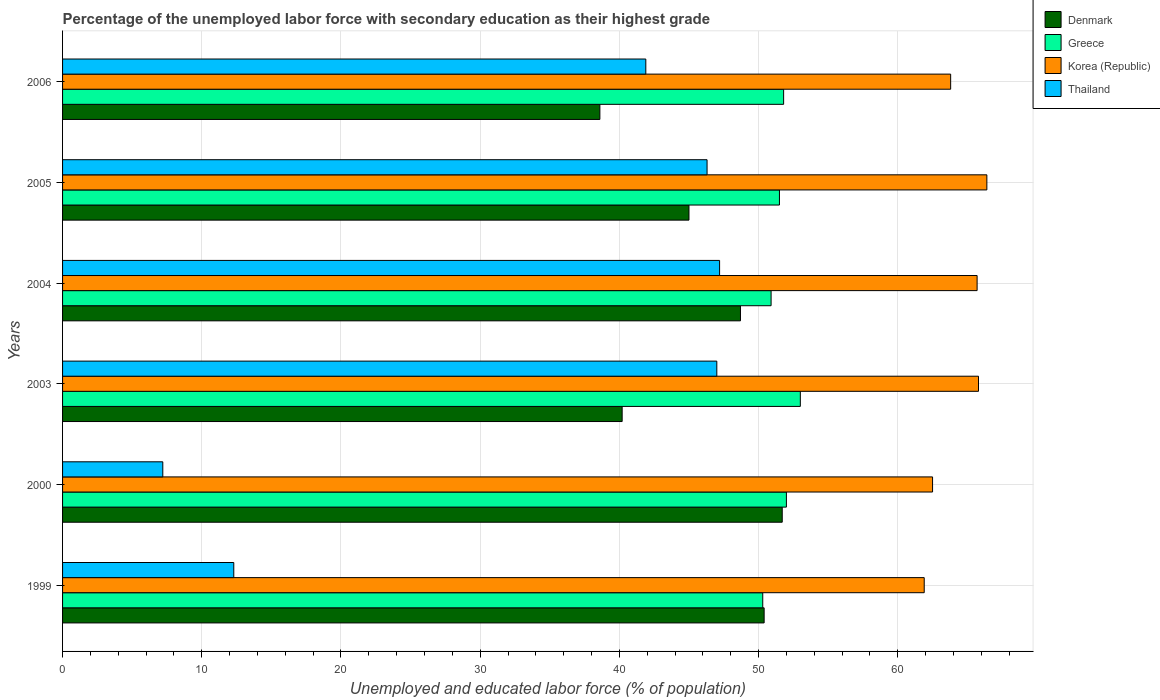How many different coloured bars are there?
Provide a short and direct response. 4. How many groups of bars are there?
Ensure brevity in your answer.  6. Are the number of bars on each tick of the Y-axis equal?
Make the answer very short. Yes. What is the label of the 1st group of bars from the top?
Provide a succinct answer. 2006. In how many cases, is the number of bars for a given year not equal to the number of legend labels?
Your answer should be very brief. 0. What is the percentage of the unemployed labor force with secondary education in Greece in 1999?
Offer a terse response. 50.3. Across all years, what is the maximum percentage of the unemployed labor force with secondary education in Denmark?
Provide a short and direct response. 51.7. Across all years, what is the minimum percentage of the unemployed labor force with secondary education in Thailand?
Offer a very short reply. 7.2. In which year was the percentage of the unemployed labor force with secondary education in Thailand minimum?
Give a very brief answer. 2000. What is the total percentage of the unemployed labor force with secondary education in Denmark in the graph?
Provide a succinct answer. 274.6. What is the difference between the percentage of the unemployed labor force with secondary education in Thailand in 1999 and that in 2004?
Ensure brevity in your answer.  -34.9. What is the difference between the percentage of the unemployed labor force with secondary education in Greece in 2006 and the percentage of the unemployed labor force with secondary education in Denmark in 2000?
Provide a succinct answer. 0.1. What is the average percentage of the unemployed labor force with secondary education in Greece per year?
Ensure brevity in your answer.  51.58. In the year 2005, what is the difference between the percentage of the unemployed labor force with secondary education in Greece and percentage of the unemployed labor force with secondary education in Thailand?
Make the answer very short. 5.2. In how many years, is the percentage of the unemployed labor force with secondary education in Korea (Republic) greater than 6 %?
Offer a terse response. 6. What is the ratio of the percentage of the unemployed labor force with secondary education in Denmark in 2003 to that in 2006?
Ensure brevity in your answer.  1.04. What is the difference between the highest and the lowest percentage of the unemployed labor force with secondary education in Thailand?
Keep it short and to the point. 40. In how many years, is the percentage of the unemployed labor force with secondary education in Greece greater than the average percentage of the unemployed labor force with secondary education in Greece taken over all years?
Your answer should be compact. 3. What does the 1st bar from the top in 2004 represents?
Keep it short and to the point. Thailand. What does the 4th bar from the bottom in 1999 represents?
Your answer should be compact. Thailand. Is it the case that in every year, the sum of the percentage of the unemployed labor force with secondary education in Denmark and percentage of the unemployed labor force with secondary education in Greece is greater than the percentage of the unemployed labor force with secondary education in Thailand?
Provide a succinct answer. Yes. How many bars are there?
Keep it short and to the point. 24. How many years are there in the graph?
Provide a short and direct response. 6. Are the values on the major ticks of X-axis written in scientific E-notation?
Your answer should be very brief. No. Does the graph contain any zero values?
Make the answer very short. No. How many legend labels are there?
Offer a terse response. 4. What is the title of the graph?
Ensure brevity in your answer.  Percentage of the unemployed labor force with secondary education as their highest grade. What is the label or title of the X-axis?
Provide a succinct answer. Unemployed and educated labor force (% of population). What is the label or title of the Y-axis?
Offer a very short reply. Years. What is the Unemployed and educated labor force (% of population) of Denmark in 1999?
Ensure brevity in your answer.  50.4. What is the Unemployed and educated labor force (% of population) of Greece in 1999?
Your response must be concise. 50.3. What is the Unemployed and educated labor force (% of population) of Korea (Republic) in 1999?
Keep it short and to the point. 61.9. What is the Unemployed and educated labor force (% of population) in Thailand in 1999?
Keep it short and to the point. 12.3. What is the Unemployed and educated labor force (% of population) in Denmark in 2000?
Your response must be concise. 51.7. What is the Unemployed and educated labor force (% of population) in Greece in 2000?
Give a very brief answer. 52. What is the Unemployed and educated labor force (% of population) of Korea (Republic) in 2000?
Offer a terse response. 62.5. What is the Unemployed and educated labor force (% of population) in Thailand in 2000?
Ensure brevity in your answer.  7.2. What is the Unemployed and educated labor force (% of population) in Denmark in 2003?
Your answer should be very brief. 40.2. What is the Unemployed and educated labor force (% of population) of Korea (Republic) in 2003?
Provide a succinct answer. 65.8. What is the Unemployed and educated labor force (% of population) of Thailand in 2003?
Your answer should be very brief. 47. What is the Unemployed and educated labor force (% of population) in Denmark in 2004?
Ensure brevity in your answer.  48.7. What is the Unemployed and educated labor force (% of population) of Greece in 2004?
Your answer should be very brief. 50.9. What is the Unemployed and educated labor force (% of population) in Korea (Republic) in 2004?
Give a very brief answer. 65.7. What is the Unemployed and educated labor force (% of population) in Thailand in 2004?
Make the answer very short. 47.2. What is the Unemployed and educated labor force (% of population) in Greece in 2005?
Offer a very short reply. 51.5. What is the Unemployed and educated labor force (% of population) in Korea (Republic) in 2005?
Keep it short and to the point. 66.4. What is the Unemployed and educated labor force (% of population) in Thailand in 2005?
Offer a very short reply. 46.3. What is the Unemployed and educated labor force (% of population) of Denmark in 2006?
Provide a short and direct response. 38.6. What is the Unemployed and educated labor force (% of population) in Greece in 2006?
Keep it short and to the point. 51.8. What is the Unemployed and educated labor force (% of population) of Korea (Republic) in 2006?
Your answer should be very brief. 63.8. What is the Unemployed and educated labor force (% of population) in Thailand in 2006?
Your answer should be very brief. 41.9. Across all years, what is the maximum Unemployed and educated labor force (% of population) in Denmark?
Your answer should be compact. 51.7. Across all years, what is the maximum Unemployed and educated labor force (% of population) of Greece?
Provide a short and direct response. 53. Across all years, what is the maximum Unemployed and educated labor force (% of population) in Korea (Republic)?
Offer a terse response. 66.4. Across all years, what is the maximum Unemployed and educated labor force (% of population) in Thailand?
Provide a short and direct response. 47.2. Across all years, what is the minimum Unemployed and educated labor force (% of population) in Denmark?
Your response must be concise. 38.6. Across all years, what is the minimum Unemployed and educated labor force (% of population) of Greece?
Ensure brevity in your answer.  50.3. Across all years, what is the minimum Unemployed and educated labor force (% of population) of Korea (Republic)?
Your answer should be very brief. 61.9. Across all years, what is the minimum Unemployed and educated labor force (% of population) of Thailand?
Offer a terse response. 7.2. What is the total Unemployed and educated labor force (% of population) in Denmark in the graph?
Provide a succinct answer. 274.6. What is the total Unemployed and educated labor force (% of population) in Greece in the graph?
Your answer should be very brief. 309.5. What is the total Unemployed and educated labor force (% of population) in Korea (Republic) in the graph?
Keep it short and to the point. 386.1. What is the total Unemployed and educated labor force (% of population) of Thailand in the graph?
Ensure brevity in your answer.  201.9. What is the difference between the Unemployed and educated labor force (% of population) of Denmark in 1999 and that in 2000?
Offer a very short reply. -1.3. What is the difference between the Unemployed and educated labor force (% of population) in Korea (Republic) in 1999 and that in 2000?
Keep it short and to the point. -0.6. What is the difference between the Unemployed and educated labor force (% of population) in Thailand in 1999 and that in 2000?
Give a very brief answer. 5.1. What is the difference between the Unemployed and educated labor force (% of population) of Greece in 1999 and that in 2003?
Make the answer very short. -2.7. What is the difference between the Unemployed and educated labor force (% of population) in Korea (Republic) in 1999 and that in 2003?
Ensure brevity in your answer.  -3.9. What is the difference between the Unemployed and educated labor force (% of population) of Thailand in 1999 and that in 2003?
Make the answer very short. -34.7. What is the difference between the Unemployed and educated labor force (% of population) of Denmark in 1999 and that in 2004?
Offer a very short reply. 1.7. What is the difference between the Unemployed and educated labor force (% of population) of Greece in 1999 and that in 2004?
Make the answer very short. -0.6. What is the difference between the Unemployed and educated labor force (% of population) in Thailand in 1999 and that in 2004?
Keep it short and to the point. -34.9. What is the difference between the Unemployed and educated labor force (% of population) of Korea (Republic) in 1999 and that in 2005?
Provide a succinct answer. -4.5. What is the difference between the Unemployed and educated labor force (% of population) of Thailand in 1999 and that in 2005?
Give a very brief answer. -34. What is the difference between the Unemployed and educated labor force (% of population) of Denmark in 1999 and that in 2006?
Your answer should be compact. 11.8. What is the difference between the Unemployed and educated labor force (% of population) of Greece in 1999 and that in 2006?
Offer a terse response. -1.5. What is the difference between the Unemployed and educated labor force (% of population) of Thailand in 1999 and that in 2006?
Offer a terse response. -29.6. What is the difference between the Unemployed and educated labor force (% of population) in Denmark in 2000 and that in 2003?
Provide a succinct answer. 11.5. What is the difference between the Unemployed and educated labor force (% of population) in Korea (Republic) in 2000 and that in 2003?
Make the answer very short. -3.3. What is the difference between the Unemployed and educated labor force (% of population) in Thailand in 2000 and that in 2003?
Make the answer very short. -39.8. What is the difference between the Unemployed and educated labor force (% of population) of Thailand in 2000 and that in 2004?
Your answer should be very brief. -40. What is the difference between the Unemployed and educated labor force (% of population) in Denmark in 2000 and that in 2005?
Offer a very short reply. 6.7. What is the difference between the Unemployed and educated labor force (% of population) of Thailand in 2000 and that in 2005?
Offer a very short reply. -39.1. What is the difference between the Unemployed and educated labor force (% of population) of Korea (Republic) in 2000 and that in 2006?
Offer a terse response. -1.3. What is the difference between the Unemployed and educated labor force (% of population) of Thailand in 2000 and that in 2006?
Your response must be concise. -34.7. What is the difference between the Unemployed and educated labor force (% of population) in Greece in 2003 and that in 2004?
Keep it short and to the point. 2.1. What is the difference between the Unemployed and educated labor force (% of population) in Korea (Republic) in 2003 and that in 2004?
Ensure brevity in your answer.  0.1. What is the difference between the Unemployed and educated labor force (% of population) in Thailand in 2003 and that in 2004?
Provide a short and direct response. -0.2. What is the difference between the Unemployed and educated labor force (% of population) in Greece in 2003 and that in 2005?
Give a very brief answer. 1.5. What is the difference between the Unemployed and educated labor force (% of population) of Thailand in 2003 and that in 2005?
Provide a short and direct response. 0.7. What is the difference between the Unemployed and educated labor force (% of population) in Greece in 2003 and that in 2006?
Offer a terse response. 1.2. What is the difference between the Unemployed and educated labor force (% of population) of Korea (Republic) in 2003 and that in 2006?
Keep it short and to the point. 2. What is the difference between the Unemployed and educated labor force (% of population) in Thailand in 2003 and that in 2006?
Your answer should be compact. 5.1. What is the difference between the Unemployed and educated labor force (% of population) in Denmark in 2004 and that in 2005?
Give a very brief answer. 3.7. What is the difference between the Unemployed and educated labor force (% of population) in Greece in 2004 and that in 2005?
Give a very brief answer. -0.6. What is the difference between the Unemployed and educated labor force (% of population) of Thailand in 2004 and that in 2005?
Make the answer very short. 0.9. What is the difference between the Unemployed and educated labor force (% of population) in Denmark in 2004 and that in 2006?
Your answer should be compact. 10.1. What is the difference between the Unemployed and educated labor force (% of population) in Korea (Republic) in 2004 and that in 2006?
Provide a short and direct response. 1.9. What is the difference between the Unemployed and educated labor force (% of population) in Denmark in 1999 and the Unemployed and educated labor force (% of population) in Thailand in 2000?
Your response must be concise. 43.2. What is the difference between the Unemployed and educated labor force (% of population) of Greece in 1999 and the Unemployed and educated labor force (% of population) of Thailand in 2000?
Give a very brief answer. 43.1. What is the difference between the Unemployed and educated labor force (% of population) of Korea (Republic) in 1999 and the Unemployed and educated labor force (% of population) of Thailand in 2000?
Keep it short and to the point. 54.7. What is the difference between the Unemployed and educated labor force (% of population) of Denmark in 1999 and the Unemployed and educated labor force (% of population) of Korea (Republic) in 2003?
Your answer should be very brief. -15.4. What is the difference between the Unemployed and educated labor force (% of population) in Denmark in 1999 and the Unemployed and educated labor force (% of population) in Thailand in 2003?
Offer a very short reply. 3.4. What is the difference between the Unemployed and educated labor force (% of population) in Greece in 1999 and the Unemployed and educated labor force (% of population) in Korea (Republic) in 2003?
Ensure brevity in your answer.  -15.5. What is the difference between the Unemployed and educated labor force (% of population) of Denmark in 1999 and the Unemployed and educated labor force (% of population) of Greece in 2004?
Ensure brevity in your answer.  -0.5. What is the difference between the Unemployed and educated labor force (% of population) of Denmark in 1999 and the Unemployed and educated labor force (% of population) of Korea (Republic) in 2004?
Provide a succinct answer. -15.3. What is the difference between the Unemployed and educated labor force (% of population) in Denmark in 1999 and the Unemployed and educated labor force (% of population) in Thailand in 2004?
Provide a short and direct response. 3.2. What is the difference between the Unemployed and educated labor force (% of population) in Greece in 1999 and the Unemployed and educated labor force (% of population) in Korea (Republic) in 2004?
Offer a terse response. -15.4. What is the difference between the Unemployed and educated labor force (% of population) in Korea (Republic) in 1999 and the Unemployed and educated labor force (% of population) in Thailand in 2004?
Ensure brevity in your answer.  14.7. What is the difference between the Unemployed and educated labor force (% of population) of Denmark in 1999 and the Unemployed and educated labor force (% of population) of Korea (Republic) in 2005?
Make the answer very short. -16. What is the difference between the Unemployed and educated labor force (% of population) in Denmark in 1999 and the Unemployed and educated labor force (% of population) in Thailand in 2005?
Keep it short and to the point. 4.1. What is the difference between the Unemployed and educated labor force (% of population) of Greece in 1999 and the Unemployed and educated labor force (% of population) of Korea (Republic) in 2005?
Provide a short and direct response. -16.1. What is the difference between the Unemployed and educated labor force (% of population) of Denmark in 1999 and the Unemployed and educated labor force (% of population) of Greece in 2006?
Provide a succinct answer. -1.4. What is the difference between the Unemployed and educated labor force (% of population) of Denmark in 1999 and the Unemployed and educated labor force (% of population) of Korea (Republic) in 2006?
Provide a short and direct response. -13.4. What is the difference between the Unemployed and educated labor force (% of population) in Denmark in 1999 and the Unemployed and educated labor force (% of population) in Thailand in 2006?
Provide a short and direct response. 8.5. What is the difference between the Unemployed and educated labor force (% of population) in Denmark in 2000 and the Unemployed and educated labor force (% of population) in Greece in 2003?
Ensure brevity in your answer.  -1.3. What is the difference between the Unemployed and educated labor force (% of population) in Denmark in 2000 and the Unemployed and educated labor force (% of population) in Korea (Republic) in 2003?
Provide a succinct answer. -14.1. What is the difference between the Unemployed and educated labor force (% of population) of Greece in 2000 and the Unemployed and educated labor force (% of population) of Korea (Republic) in 2003?
Ensure brevity in your answer.  -13.8. What is the difference between the Unemployed and educated labor force (% of population) in Greece in 2000 and the Unemployed and educated labor force (% of population) in Thailand in 2003?
Make the answer very short. 5. What is the difference between the Unemployed and educated labor force (% of population) of Korea (Republic) in 2000 and the Unemployed and educated labor force (% of population) of Thailand in 2003?
Your response must be concise. 15.5. What is the difference between the Unemployed and educated labor force (% of population) of Denmark in 2000 and the Unemployed and educated labor force (% of population) of Greece in 2004?
Your answer should be compact. 0.8. What is the difference between the Unemployed and educated labor force (% of population) in Denmark in 2000 and the Unemployed and educated labor force (% of population) in Korea (Republic) in 2004?
Offer a terse response. -14. What is the difference between the Unemployed and educated labor force (% of population) of Denmark in 2000 and the Unemployed and educated labor force (% of population) of Thailand in 2004?
Offer a terse response. 4.5. What is the difference between the Unemployed and educated labor force (% of population) in Greece in 2000 and the Unemployed and educated labor force (% of population) in Korea (Republic) in 2004?
Give a very brief answer. -13.7. What is the difference between the Unemployed and educated labor force (% of population) in Greece in 2000 and the Unemployed and educated labor force (% of population) in Thailand in 2004?
Your response must be concise. 4.8. What is the difference between the Unemployed and educated labor force (% of population) in Denmark in 2000 and the Unemployed and educated labor force (% of population) in Korea (Republic) in 2005?
Keep it short and to the point. -14.7. What is the difference between the Unemployed and educated labor force (% of population) in Greece in 2000 and the Unemployed and educated labor force (% of population) in Korea (Republic) in 2005?
Offer a terse response. -14.4. What is the difference between the Unemployed and educated labor force (% of population) of Greece in 2000 and the Unemployed and educated labor force (% of population) of Korea (Republic) in 2006?
Provide a succinct answer. -11.8. What is the difference between the Unemployed and educated labor force (% of population) of Korea (Republic) in 2000 and the Unemployed and educated labor force (% of population) of Thailand in 2006?
Your answer should be very brief. 20.6. What is the difference between the Unemployed and educated labor force (% of population) of Denmark in 2003 and the Unemployed and educated labor force (% of population) of Greece in 2004?
Your response must be concise. -10.7. What is the difference between the Unemployed and educated labor force (% of population) of Denmark in 2003 and the Unemployed and educated labor force (% of population) of Korea (Republic) in 2004?
Keep it short and to the point. -25.5. What is the difference between the Unemployed and educated labor force (% of population) in Denmark in 2003 and the Unemployed and educated labor force (% of population) in Thailand in 2004?
Your answer should be very brief. -7. What is the difference between the Unemployed and educated labor force (% of population) in Greece in 2003 and the Unemployed and educated labor force (% of population) in Korea (Republic) in 2004?
Provide a short and direct response. -12.7. What is the difference between the Unemployed and educated labor force (% of population) of Greece in 2003 and the Unemployed and educated labor force (% of population) of Thailand in 2004?
Keep it short and to the point. 5.8. What is the difference between the Unemployed and educated labor force (% of population) of Korea (Republic) in 2003 and the Unemployed and educated labor force (% of population) of Thailand in 2004?
Offer a terse response. 18.6. What is the difference between the Unemployed and educated labor force (% of population) of Denmark in 2003 and the Unemployed and educated labor force (% of population) of Korea (Republic) in 2005?
Your response must be concise. -26.2. What is the difference between the Unemployed and educated labor force (% of population) in Denmark in 2003 and the Unemployed and educated labor force (% of population) in Thailand in 2005?
Offer a very short reply. -6.1. What is the difference between the Unemployed and educated labor force (% of population) in Greece in 2003 and the Unemployed and educated labor force (% of population) in Thailand in 2005?
Your answer should be very brief. 6.7. What is the difference between the Unemployed and educated labor force (% of population) of Denmark in 2003 and the Unemployed and educated labor force (% of population) of Korea (Republic) in 2006?
Your response must be concise. -23.6. What is the difference between the Unemployed and educated labor force (% of population) in Denmark in 2003 and the Unemployed and educated labor force (% of population) in Thailand in 2006?
Provide a short and direct response. -1.7. What is the difference between the Unemployed and educated labor force (% of population) in Greece in 2003 and the Unemployed and educated labor force (% of population) in Korea (Republic) in 2006?
Your answer should be very brief. -10.8. What is the difference between the Unemployed and educated labor force (% of population) in Greece in 2003 and the Unemployed and educated labor force (% of population) in Thailand in 2006?
Keep it short and to the point. 11.1. What is the difference between the Unemployed and educated labor force (% of population) of Korea (Republic) in 2003 and the Unemployed and educated labor force (% of population) of Thailand in 2006?
Your answer should be very brief. 23.9. What is the difference between the Unemployed and educated labor force (% of population) of Denmark in 2004 and the Unemployed and educated labor force (% of population) of Greece in 2005?
Offer a terse response. -2.8. What is the difference between the Unemployed and educated labor force (% of population) of Denmark in 2004 and the Unemployed and educated labor force (% of population) of Korea (Republic) in 2005?
Your response must be concise. -17.7. What is the difference between the Unemployed and educated labor force (% of population) of Greece in 2004 and the Unemployed and educated labor force (% of population) of Korea (Republic) in 2005?
Make the answer very short. -15.5. What is the difference between the Unemployed and educated labor force (% of population) of Korea (Republic) in 2004 and the Unemployed and educated labor force (% of population) of Thailand in 2005?
Give a very brief answer. 19.4. What is the difference between the Unemployed and educated labor force (% of population) in Denmark in 2004 and the Unemployed and educated labor force (% of population) in Korea (Republic) in 2006?
Provide a succinct answer. -15.1. What is the difference between the Unemployed and educated labor force (% of population) in Greece in 2004 and the Unemployed and educated labor force (% of population) in Korea (Republic) in 2006?
Provide a succinct answer. -12.9. What is the difference between the Unemployed and educated labor force (% of population) of Greece in 2004 and the Unemployed and educated labor force (% of population) of Thailand in 2006?
Make the answer very short. 9. What is the difference between the Unemployed and educated labor force (% of population) of Korea (Republic) in 2004 and the Unemployed and educated labor force (% of population) of Thailand in 2006?
Provide a succinct answer. 23.8. What is the difference between the Unemployed and educated labor force (% of population) in Denmark in 2005 and the Unemployed and educated labor force (% of population) in Greece in 2006?
Give a very brief answer. -6.8. What is the difference between the Unemployed and educated labor force (% of population) in Denmark in 2005 and the Unemployed and educated labor force (% of population) in Korea (Republic) in 2006?
Provide a short and direct response. -18.8. What is the difference between the Unemployed and educated labor force (% of population) of Denmark in 2005 and the Unemployed and educated labor force (% of population) of Thailand in 2006?
Ensure brevity in your answer.  3.1. What is the average Unemployed and educated labor force (% of population) in Denmark per year?
Offer a terse response. 45.77. What is the average Unemployed and educated labor force (% of population) in Greece per year?
Make the answer very short. 51.58. What is the average Unemployed and educated labor force (% of population) of Korea (Republic) per year?
Make the answer very short. 64.35. What is the average Unemployed and educated labor force (% of population) in Thailand per year?
Make the answer very short. 33.65. In the year 1999, what is the difference between the Unemployed and educated labor force (% of population) of Denmark and Unemployed and educated labor force (% of population) of Greece?
Provide a short and direct response. 0.1. In the year 1999, what is the difference between the Unemployed and educated labor force (% of population) of Denmark and Unemployed and educated labor force (% of population) of Korea (Republic)?
Keep it short and to the point. -11.5. In the year 1999, what is the difference between the Unemployed and educated labor force (% of population) of Denmark and Unemployed and educated labor force (% of population) of Thailand?
Ensure brevity in your answer.  38.1. In the year 1999, what is the difference between the Unemployed and educated labor force (% of population) of Greece and Unemployed and educated labor force (% of population) of Korea (Republic)?
Your answer should be very brief. -11.6. In the year 1999, what is the difference between the Unemployed and educated labor force (% of population) of Korea (Republic) and Unemployed and educated labor force (% of population) of Thailand?
Provide a succinct answer. 49.6. In the year 2000, what is the difference between the Unemployed and educated labor force (% of population) of Denmark and Unemployed and educated labor force (% of population) of Greece?
Provide a short and direct response. -0.3. In the year 2000, what is the difference between the Unemployed and educated labor force (% of population) in Denmark and Unemployed and educated labor force (% of population) in Thailand?
Keep it short and to the point. 44.5. In the year 2000, what is the difference between the Unemployed and educated labor force (% of population) of Greece and Unemployed and educated labor force (% of population) of Thailand?
Offer a very short reply. 44.8. In the year 2000, what is the difference between the Unemployed and educated labor force (% of population) of Korea (Republic) and Unemployed and educated labor force (% of population) of Thailand?
Provide a succinct answer. 55.3. In the year 2003, what is the difference between the Unemployed and educated labor force (% of population) of Denmark and Unemployed and educated labor force (% of population) of Greece?
Your answer should be very brief. -12.8. In the year 2003, what is the difference between the Unemployed and educated labor force (% of population) in Denmark and Unemployed and educated labor force (% of population) in Korea (Republic)?
Your answer should be very brief. -25.6. In the year 2003, what is the difference between the Unemployed and educated labor force (% of population) of Greece and Unemployed and educated labor force (% of population) of Thailand?
Keep it short and to the point. 6. In the year 2004, what is the difference between the Unemployed and educated labor force (% of population) of Denmark and Unemployed and educated labor force (% of population) of Thailand?
Offer a terse response. 1.5. In the year 2004, what is the difference between the Unemployed and educated labor force (% of population) of Greece and Unemployed and educated labor force (% of population) of Korea (Republic)?
Ensure brevity in your answer.  -14.8. In the year 2004, what is the difference between the Unemployed and educated labor force (% of population) in Greece and Unemployed and educated labor force (% of population) in Thailand?
Offer a terse response. 3.7. In the year 2005, what is the difference between the Unemployed and educated labor force (% of population) in Denmark and Unemployed and educated labor force (% of population) in Greece?
Provide a short and direct response. -6.5. In the year 2005, what is the difference between the Unemployed and educated labor force (% of population) of Denmark and Unemployed and educated labor force (% of population) of Korea (Republic)?
Offer a very short reply. -21.4. In the year 2005, what is the difference between the Unemployed and educated labor force (% of population) in Denmark and Unemployed and educated labor force (% of population) in Thailand?
Your answer should be compact. -1.3. In the year 2005, what is the difference between the Unemployed and educated labor force (% of population) of Greece and Unemployed and educated labor force (% of population) of Korea (Republic)?
Your answer should be compact. -14.9. In the year 2005, what is the difference between the Unemployed and educated labor force (% of population) in Greece and Unemployed and educated labor force (% of population) in Thailand?
Your answer should be compact. 5.2. In the year 2005, what is the difference between the Unemployed and educated labor force (% of population) of Korea (Republic) and Unemployed and educated labor force (% of population) of Thailand?
Provide a succinct answer. 20.1. In the year 2006, what is the difference between the Unemployed and educated labor force (% of population) in Denmark and Unemployed and educated labor force (% of population) in Greece?
Offer a very short reply. -13.2. In the year 2006, what is the difference between the Unemployed and educated labor force (% of population) in Denmark and Unemployed and educated labor force (% of population) in Korea (Republic)?
Your answer should be very brief. -25.2. In the year 2006, what is the difference between the Unemployed and educated labor force (% of population) of Denmark and Unemployed and educated labor force (% of population) of Thailand?
Ensure brevity in your answer.  -3.3. In the year 2006, what is the difference between the Unemployed and educated labor force (% of population) of Korea (Republic) and Unemployed and educated labor force (% of population) of Thailand?
Provide a succinct answer. 21.9. What is the ratio of the Unemployed and educated labor force (% of population) of Denmark in 1999 to that in 2000?
Provide a short and direct response. 0.97. What is the ratio of the Unemployed and educated labor force (% of population) in Greece in 1999 to that in 2000?
Your answer should be compact. 0.97. What is the ratio of the Unemployed and educated labor force (% of population) in Korea (Republic) in 1999 to that in 2000?
Offer a very short reply. 0.99. What is the ratio of the Unemployed and educated labor force (% of population) in Thailand in 1999 to that in 2000?
Your answer should be compact. 1.71. What is the ratio of the Unemployed and educated labor force (% of population) in Denmark in 1999 to that in 2003?
Your answer should be compact. 1.25. What is the ratio of the Unemployed and educated labor force (% of population) in Greece in 1999 to that in 2003?
Provide a succinct answer. 0.95. What is the ratio of the Unemployed and educated labor force (% of population) in Korea (Republic) in 1999 to that in 2003?
Give a very brief answer. 0.94. What is the ratio of the Unemployed and educated labor force (% of population) of Thailand in 1999 to that in 2003?
Offer a terse response. 0.26. What is the ratio of the Unemployed and educated labor force (% of population) in Denmark in 1999 to that in 2004?
Give a very brief answer. 1.03. What is the ratio of the Unemployed and educated labor force (% of population) in Korea (Republic) in 1999 to that in 2004?
Offer a very short reply. 0.94. What is the ratio of the Unemployed and educated labor force (% of population) in Thailand in 1999 to that in 2004?
Provide a short and direct response. 0.26. What is the ratio of the Unemployed and educated labor force (% of population) in Denmark in 1999 to that in 2005?
Provide a succinct answer. 1.12. What is the ratio of the Unemployed and educated labor force (% of population) in Greece in 1999 to that in 2005?
Provide a succinct answer. 0.98. What is the ratio of the Unemployed and educated labor force (% of population) in Korea (Republic) in 1999 to that in 2005?
Your answer should be compact. 0.93. What is the ratio of the Unemployed and educated labor force (% of population) of Thailand in 1999 to that in 2005?
Ensure brevity in your answer.  0.27. What is the ratio of the Unemployed and educated labor force (% of population) in Denmark in 1999 to that in 2006?
Ensure brevity in your answer.  1.31. What is the ratio of the Unemployed and educated labor force (% of population) of Greece in 1999 to that in 2006?
Your response must be concise. 0.97. What is the ratio of the Unemployed and educated labor force (% of population) in Korea (Republic) in 1999 to that in 2006?
Make the answer very short. 0.97. What is the ratio of the Unemployed and educated labor force (% of population) of Thailand in 1999 to that in 2006?
Ensure brevity in your answer.  0.29. What is the ratio of the Unemployed and educated labor force (% of population) of Denmark in 2000 to that in 2003?
Offer a terse response. 1.29. What is the ratio of the Unemployed and educated labor force (% of population) of Greece in 2000 to that in 2003?
Offer a terse response. 0.98. What is the ratio of the Unemployed and educated labor force (% of population) in Korea (Republic) in 2000 to that in 2003?
Your answer should be very brief. 0.95. What is the ratio of the Unemployed and educated labor force (% of population) of Thailand in 2000 to that in 2003?
Ensure brevity in your answer.  0.15. What is the ratio of the Unemployed and educated labor force (% of population) in Denmark in 2000 to that in 2004?
Your answer should be compact. 1.06. What is the ratio of the Unemployed and educated labor force (% of population) in Greece in 2000 to that in 2004?
Make the answer very short. 1.02. What is the ratio of the Unemployed and educated labor force (% of population) of Korea (Republic) in 2000 to that in 2004?
Offer a very short reply. 0.95. What is the ratio of the Unemployed and educated labor force (% of population) of Thailand in 2000 to that in 2004?
Keep it short and to the point. 0.15. What is the ratio of the Unemployed and educated labor force (% of population) of Denmark in 2000 to that in 2005?
Offer a very short reply. 1.15. What is the ratio of the Unemployed and educated labor force (% of population) in Greece in 2000 to that in 2005?
Keep it short and to the point. 1.01. What is the ratio of the Unemployed and educated labor force (% of population) in Korea (Republic) in 2000 to that in 2005?
Ensure brevity in your answer.  0.94. What is the ratio of the Unemployed and educated labor force (% of population) of Thailand in 2000 to that in 2005?
Make the answer very short. 0.16. What is the ratio of the Unemployed and educated labor force (% of population) in Denmark in 2000 to that in 2006?
Offer a terse response. 1.34. What is the ratio of the Unemployed and educated labor force (% of population) in Korea (Republic) in 2000 to that in 2006?
Keep it short and to the point. 0.98. What is the ratio of the Unemployed and educated labor force (% of population) of Thailand in 2000 to that in 2006?
Your response must be concise. 0.17. What is the ratio of the Unemployed and educated labor force (% of population) in Denmark in 2003 to that in 2004?
Offer a very short reply. 0.83. What is the ratio of the Unemployed and educated labor force (% of population) of Greece in 2003 to that in 2004?
Offer a very short reply. 1.04. What is the ratio of the Unemployed and educated labor force (% of population) of Denmark in 2003 to that in 2005?
Your answer should be compact. 0.89. What is the ratio of the Unemployed and educated labor force (% of population) of Greece in 2003 to that in 2005?
Provide a succinct answer. 1.03. What is the ratio of the Unemployed and educated labor force (% of population) of Thailand in 2003 to that in 2005?
Provide a succinct answer. 1.02. What is the ratio of the Unemployed and educated labor force (% of population) in Denmark in 2003 to that in 2006?
Provide a short and direct response. 1.04. What is the ratio of the Unemployed and educated labor force (% of population) in Greece in 2003 to that in 2006?
Provide a short and direct response. 1.02. What is the ratio of the Unemployed and educated labor force (% of population) of Korea (Republic) in 2003 to that in 2006?
Ensure brevity in your answer.  1.03. What is the ratio of the Unemployed and educated labor force (% of population) of Thailand in 2003 to that in 2006?
Offer a terse response. 1.12. What is the ratio of the Unemployed and educated labor force (% of population) of Denmark in 2004 to that in 2005?
Offer a terse response. 1.08. What is the ratio of the Unemployed and educated labor force (% of population) in Greece in 2004 to that in 2005?
Make the answer very short. 0.99. What is the ratio of the Unemployed and educated labor force (% of population) of Thailand in 2004 to that in 2005?
Provide a succinct answer. 1.02. What is the ratio of the Unemployed and educated labor force (% of population) of Denmark in 2004 to that in 2006?
Give a very brief answer. 1.26. What is the ratio of the Unemployed and educated labor force (% of population) of Greece in 2004 to that in 2006?
Ensure brevity in your answer.  0.98. What is the ratio of the Unemployed and educated labor force (% of population) of Korea (Republic) in 2004 to that in 2006?
Your answer should be very brief. 1.03. What is the ratio of the Unemployed and educated labor force (% of population) of Thailand in 2004 to that in 2006?
Your answer should be compact. 1.13. What is the ratio of the Unemployed and educated labor force (% of population) in Denmark in 2005 to that in 2006?
Your answer should be compact. 1.17. What is the ratio of the Unemployed and educated labor force (% of population) of Korea (Republic) in 2005 to that in 2006?
Your response must be concise. 1.04. What is the ratio of the Unemployed and educated labor force (% of population) of Thailand in 2005 to that in 2006?
Ensure brevity in your answer.  1.1. What is the difference between the highest and the second highest Unemployed and educated labor force (% of population) in Korea (Republic)?
Your answer should be very brief. 0.6. What is the difference between the highest and the second highest Unemployed and educated labor force (% of population) in Thailand?
Provide a short and direct response. 0.2. What is the difference between the highest and the lowest Unemployed and educated labor force (% of population) of Denmark?
Your response must be concise. 13.1. What is the difference between the highest and the lowest Unemployed and educated labor force (% of population) in Greece?
Provide a short and direct response. 2.7. What is the difference between the highest and the lowest Unemployed and educated labor force (% of population) in Korea (Republic)?
Provide a short and direct response. 4.5. What is the difference between the highest and the lowest Unemployed and educated labor force (% of population) in Thailand?
Give a very brief answer. 40. 